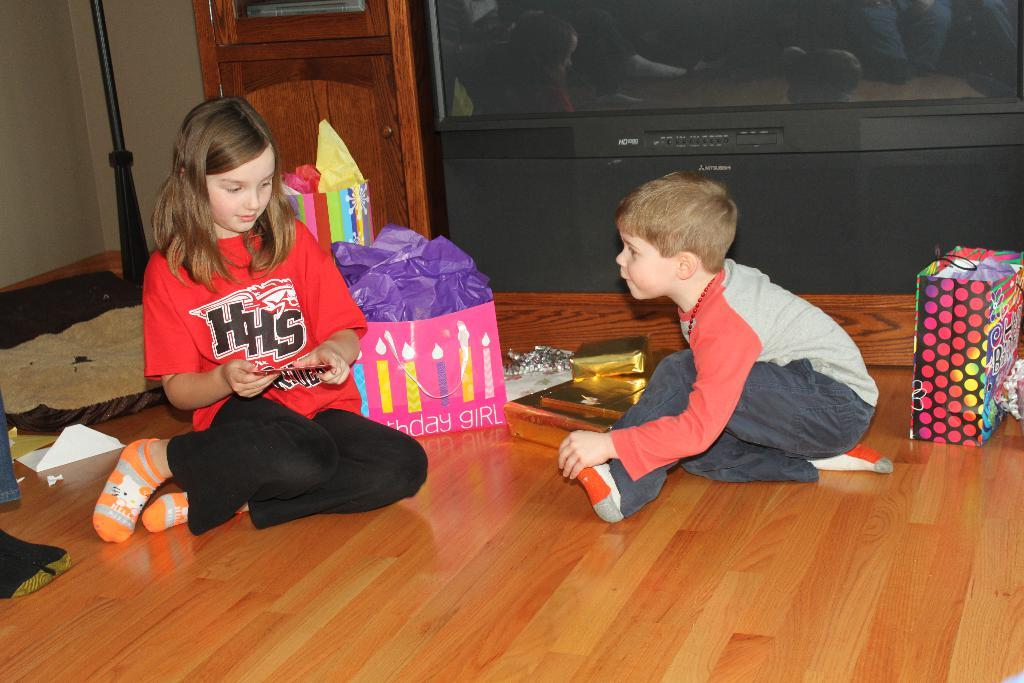How many people are in the image? There are two people in the image, a girl and a boy. What are the girl and the boy doing in the image? Both the girl and the boy are sitting on the floor. What is the floor made of? The floor is made of wood. What can be seen in the background of the image? There is a TV and a cupboard in the background. What is on the left side of the image? There is a wall on the left side of the image. What type of beam is being used by the girl in the image? There is no beam present in the image; the girl is simply sitting on the wooden floor. 